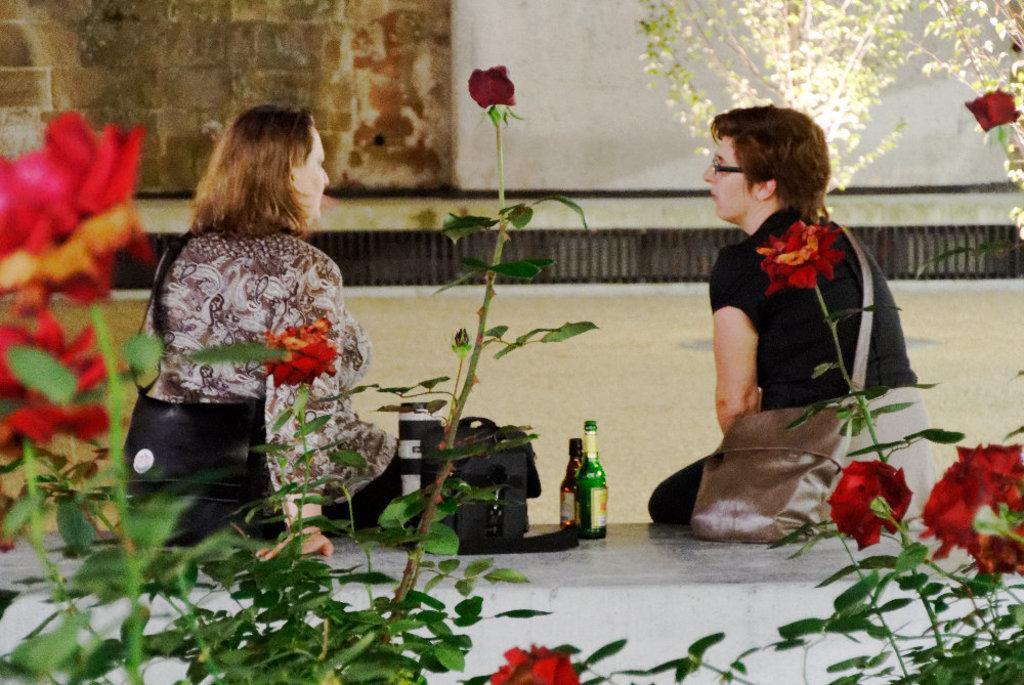Please provide a concise description of this image. In this image, we can see rose plants and there are some people sitting on the stone and are wearing bags and we can see a bag and bottles and there is a wall. At the bottom, there is road and we can see a grille. 